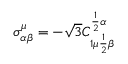Convert formula to latex. <formula><loc_0><loc_0><loc_500><loc_500>\sigma _ { \alpha \beta } ^ { \mu } = - \sqrt { 3 } C _ { 1 \mu { \frac { 1 } { 2 } } \beta } ^ { { \frac { 1 } { 2 } } \alpha }</formula> 